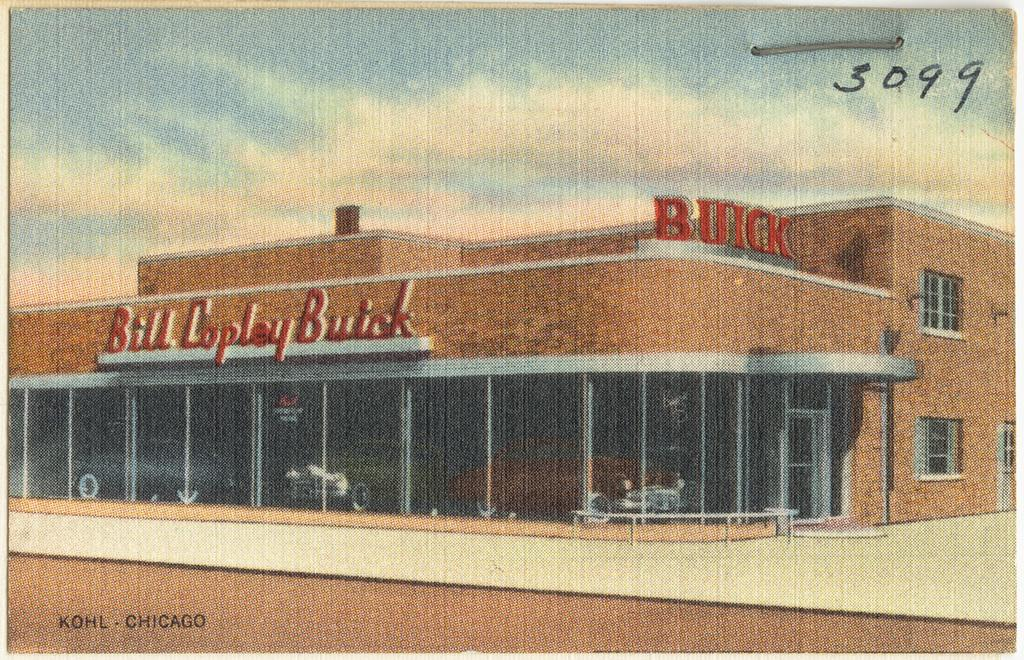What is the main subject of the poster in the image? The poster contains a picture of a building. What can be seen in the sky at the top of the image? The sky and clouds are visible at the top of the image. Where is the watermark located in the image? The watermark is in the bottom left corner of the image. What thought does the grandfather have after seeing the poster in the image? There is no grandfather present in the image, so it is not possible to determine any thoughts he might have. 